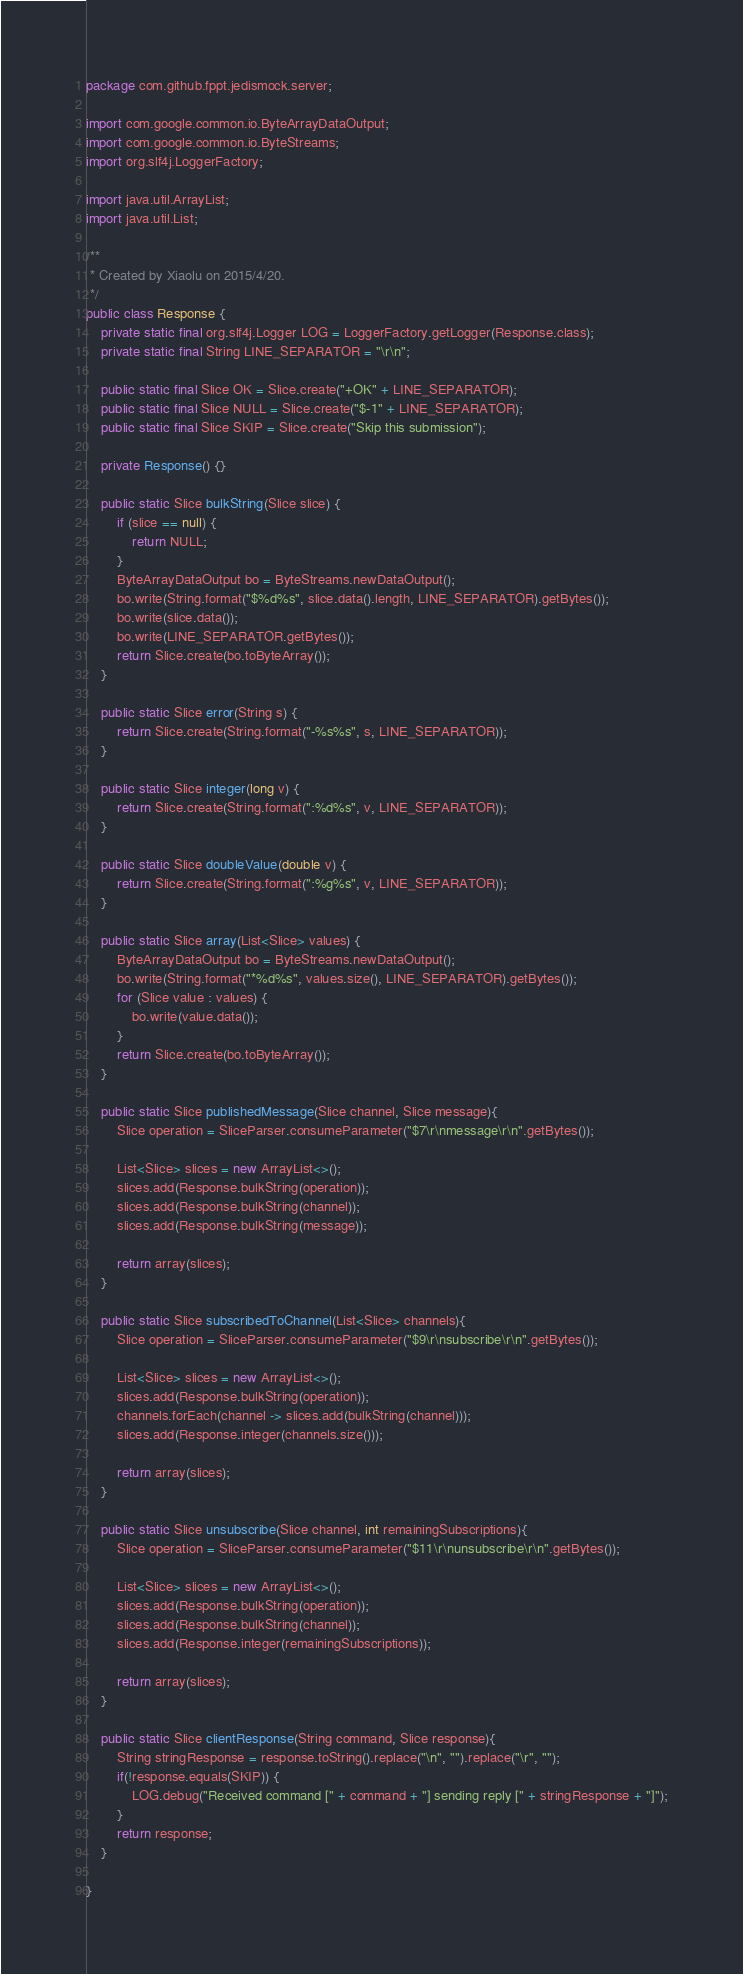<code> <loc_0><loc_0><loc_500><loc_500><_Java_>package com.github.fppt.jedismock.server;

import com.google.common.io.ByteArrayDataOutput;
import com.google.common.io.ByteStreams;
import org.slf4j.LoggerFactory;

import java.util.ArrayList;
import java.util.List;

/**
 * Created by Xiaolu on 2015/4/20.
 */
public class Response {
    private static final org.slf4j.Logger LOG = LoggerFactory.getLogger(Response.class);
    private static final String LINE_SEPARATOR = "\r\n";

    public static final Slice OK = Slice.create("+OK" + LINE_SEPARATOR);
    public static final Slice NULL = Slice.create("$-1" + LINE_SEPARATOR);
    public static final Slice SKIP = Slice.create("Skip this submission");

    private Response() {}

    public static Slice bulkString(Slice slice) {
        if (slice == null) {
            return NULL;
        }
        ByteArrayDataOutput bo = ByteStreams.newDataOutput();
        bo.write(String.format("$%d%s", slice.data().length, LINE_SEPARATOR).getBytes());
        bo.write(slice.data());
        bo.write(LINE_SEPARATOR.getBytes());
        return Slice.create(bo.toByteArray());
    }

    public static Slice error(String s) {
        return Slice.create(String.format("-%s%s", s, LINE_SEPARATOR));
    }

    public static Slice integer(long v) {
        return Slice.create(String.format(":%d%s", v, LINE_SEPARATOR));
    }

    public static Slice doubleValue(double v) {
        return Slice.create(String.format(":%g%s", v, LINE_SEPARATOR));
    }

    public static Slice array(List<Slice> values) {
        ByteArrayDataOutput bo = ByteStreams.newDataOutput();
        bo.write(String.format("*%d%s", values.size(), LINE_SEPARATOR).getBytes());
        for (Slice value : values) {
            bo.write(value.data());
        }
        return Slice.create(bo.toByteArray());
    }

    public static Slice publishedMessage(Slice channel, Slice message){
        Slice operation = SliceParser.consumeParameter("$7\r\nmessage\r\n".getBytes());

        List<Slice> slices = new ArrayList<>();
        slices.add(Response.bulkString(operation));
        slices.add(Response.bulkString(channel));
        slices.add(Response.bulkString(message));

        return array(slices);
    }

    public static Slice subscribedToChannel(List<Slice> channels){
        Slice operation = SliceParser.consumeParameter("$9\r\nsubscribe\r\n".getBytes());

        List<Slice> slices = new ArrayList<>();
        slices.add(Response.bulkString(operation));
        channels.forEach(channel -> slices.add(bulkString(channel)));
        slices.add(Response.integer(channels.size()));

        return array(slices);
    }

    public static Slice unsubscribe(Slice channel, int remainingSubscriptions){
        Slice operation = SliceParser.consumeParameter("$11\r\nunsubscribe\r\n".getBytes());

        List<Slice> slices = new ArrayList<>();
        slices.add(Response.bulkString(operation));
        slices.add(Response.bulkString(channel));
        slices.add(Response.integer(remainingSubscriptions));

        return array(slices);
    }

    public static Slice clientResponse(String command, Slice response){
        String stringResponse = response.toString().replace("\n", "").replace("\r", "");
        if(!response.equals(SKIP)) {
            LOG.debug("Received command [" + command + "] sending reply [" + stringResponse + "]");
        }
        return response;
    }

}
</code> 